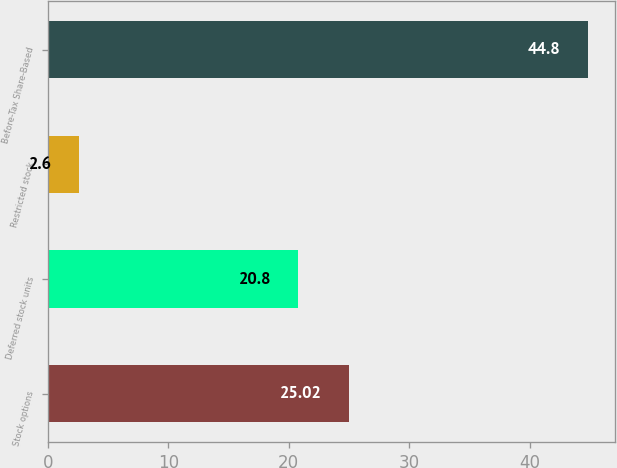<chart> <loc_0><loc_0><loc_500><loc_500><bar_chart><fcel>Stock options<fcel>Deferred stock units<fcel>Restricted stock<fcel>Before-Tax Share-Based<nl><fcel>25.02<fcel>20.8<fcel>2.6<fcel>44.8<nl></chart> 